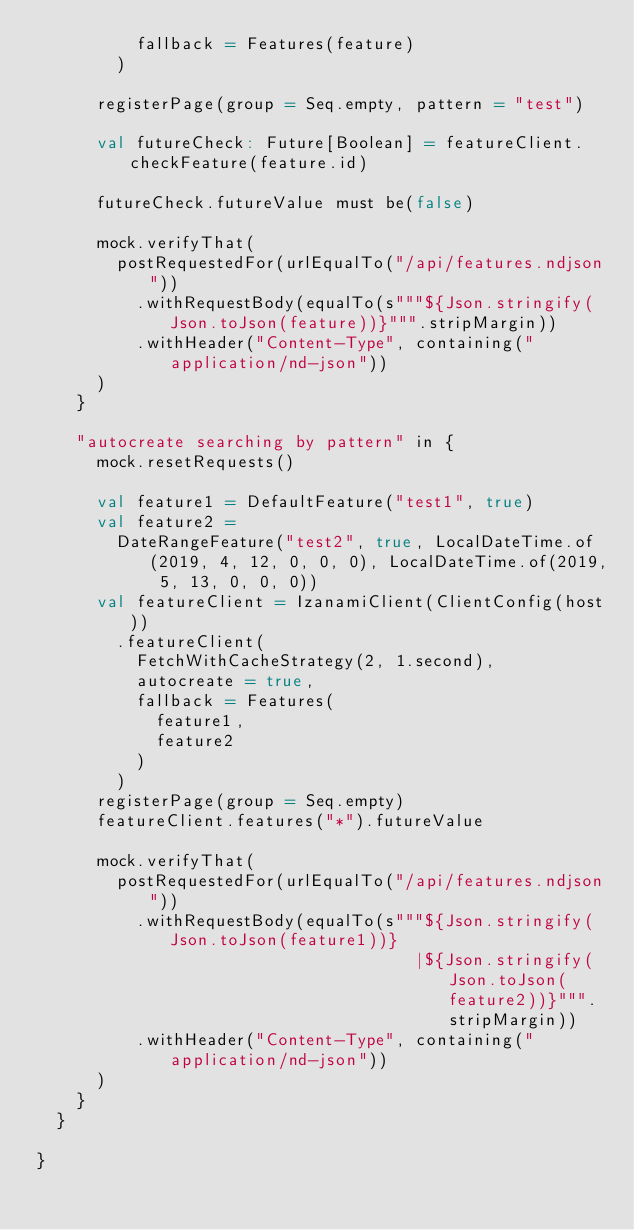<code> <loc_0><loc_0><loc_500><loc_500><_Scala_>          fallback = Features(feature)
        )

      registerPage(group = Seq.empty, pattern = "test")

      val futureCheck: Future[Boolean] = featureClient.checkFeature(feature.id)

      futureCheck.futureValue must be(false)

      mock.verifyThat(
        postRequestedFor(urlEqualTo("/api/features.ndjson"))
          .withRequestBody(equalTo(s"""${Json.stringify(Json.toJson(feature))}""".stripMargin))
          .withHeader("Content-Type", containing("application/nd-json"))
      )
    }

    "autocreate searching by pattern" in {
      mock.resetRequests()

      val feature1 = DefaultFeature("test1", true)
      val feature2 =
        DateRangeFeature("test2", true, LocalDateTime.of(2019, 4, 12, 0, 0, 0), LocalDateTime.of(2019, 5, 13, 0, 0, 0))
      val featureClient = IzanamiClient(ClientConfig(host))
        .featureClient(
          FetchWithCacheStrategy(2, 1.second),
          autocreate = true,
          fallback = Features(
            feature1,
            feature2
          )
        )
      registerPage(group = Seq.empty)
      featureClient.features("*").futureValue

      mock.verifyThat(
        postRequestedFor(urlEqualTo("/api/features.ndjson"))
          .withRequestBody(equalTo(s"""${Json.stringify(Json.toJson(feature1))}
                                      |${Json.stringify(Json.toJson(feature2))}""".stripMargin))
          .withHeader("Content-Type", containing("application/nd-json"))
      )
    }
  }

}
</code> 